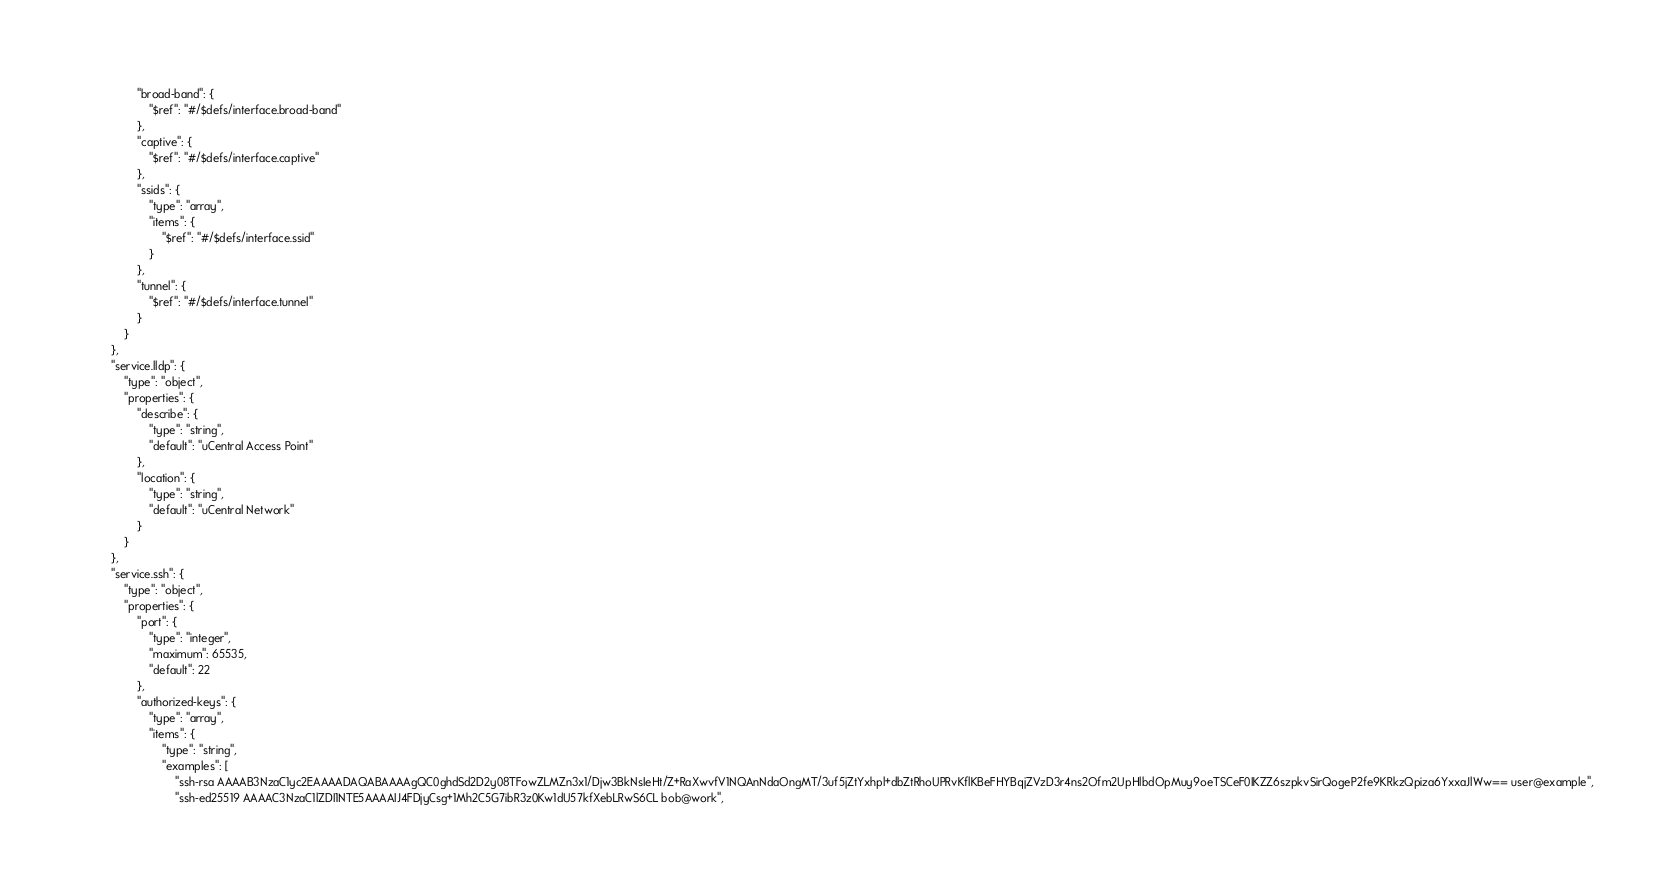<code> <loc_0><loc_0><loc_500><loc_500><_C++_>				"broad-band": {
					"$ref": "#/$defs/interface.broad-band"
				},
				"captive": {
					"$ref": "#/$defs/interface.captive"
				},
				"ssids": {
					"type": "array",
					"items": {
						"$ref": "#/$defs/interface.ssid"
					}
				},
				"tunnel": {
					"$ref": "#/$defs/interface.tunnel"
				}
			}
		},
		"service.lldp": {
			"type": "object",
			"properties": {
				"describe": {
					"type": "string",
					"default": "uCentral Access Point"
				},
				"location": {
					"type": "string",
					"default": "uCentral Network"
				}
			}
		},
		"service.ssh": {
			"type": "object",
			"properties": {
				"port": {
					"type": "integer",
					"maximum": 65535,
					"default": 22
				},
				"authorized-keys": {
					"type": "array",
					"items": {
						"type": "string",
						"examples": [
							"ssh-rsa AAAAB3NzaC1yc2EAAAADAQABAAAAgQC0ghdSd2D2y08TFowZLMZn3x1/Djw3BkNsIeHt/Z+RaXwvfV1NQAnNdaOngMT/3uf5jZtYxhpl+dbZtRhoUPRvKflKBeFHYBqjZVzD3r4ns2Ofm2UpHlbdOpMuy9oeTSCeF0IKZZ6szpkvSirQogeP2fe9KRkzQpiza6YxxaJlWw== user@example",
							"ssh-ed25519 AAAAC3NzaC1lZDI1NTE5AAAAIJ4FDjyCsg+1Mh2C5G7ibR3z0Kw1dU57kfXebLRwS6CL bob@work",</code> 